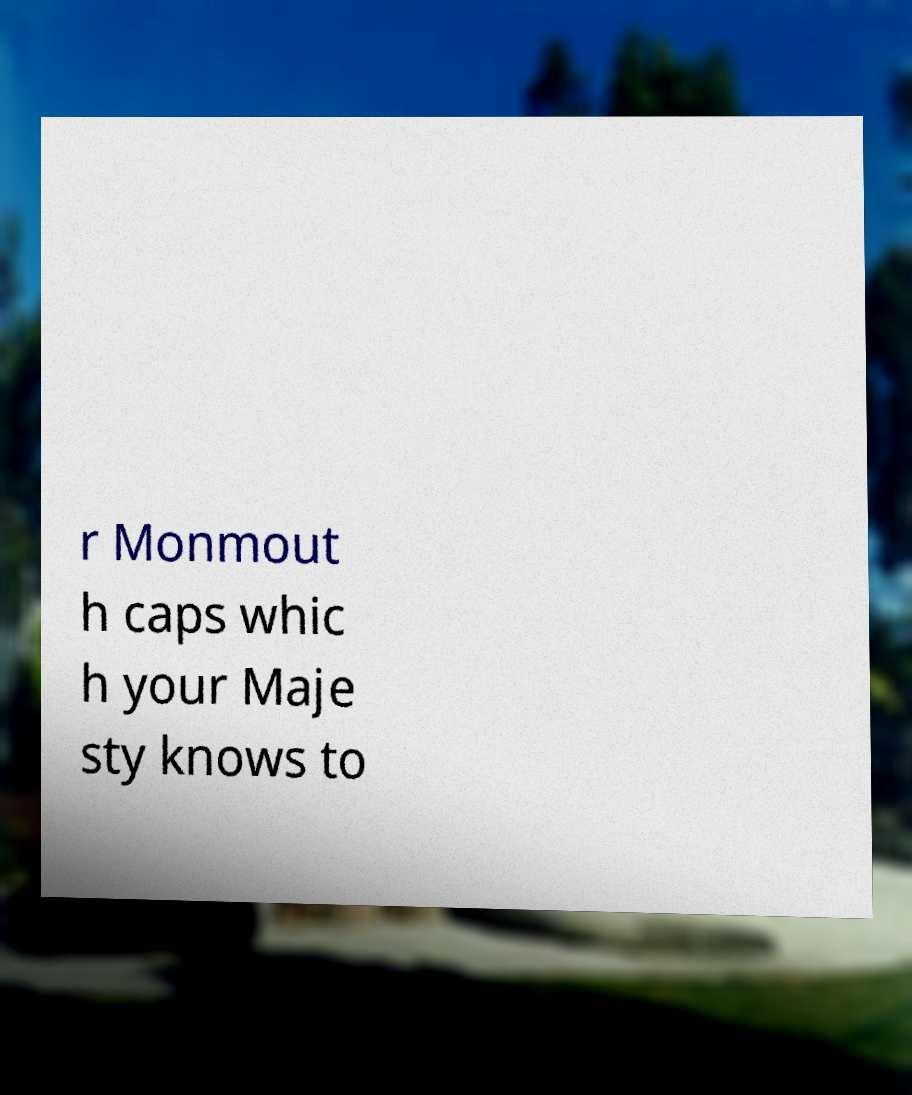For documentation purposes, I need the text within this image transcribed. Could you provide that? r Monmout h caps whic h your Maje sty knows to 